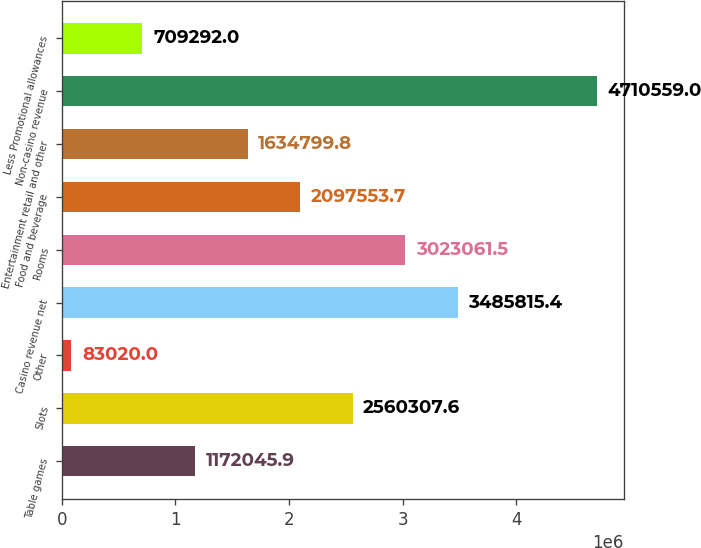Convert chart. <chart><loc_0><loc_0><loc_500><loc_500><bar_chart><fcel>Table games<fcel>Slots<fcel>Other<fcel>Casino revenue net<fcel>Rooms<fcel>Food and beverage<fcel>Entertainment retail and other<fcel>Non-casino revenue<fcel>Less Promotional allowances<nl><fcel>1.17205e+06<fcel>2.56031e+06<fcel>83020<fcel>3.48582e+06<fcel>3.02306e+06<fcel>2.09755e+06<fcel>1.6348e+06<fcel>4.71056e+06<fcel>709292<nl></chart> 